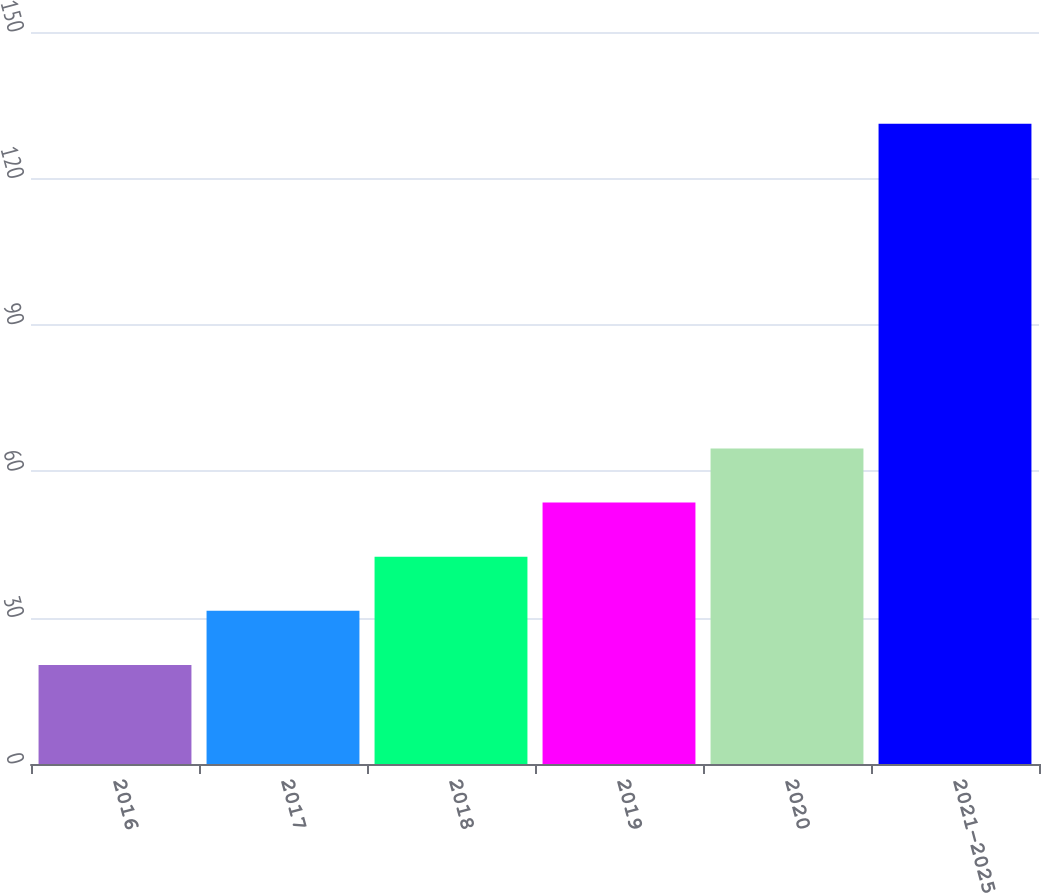<chart> <loc_0><loc_0><loc_500><loc_500><bar_chart><fcel>2016<fcel>2017<fcel>2018<fcel>2019<fcel>2020<fcel>2021-2025<nl><fcel>20.3<fcel>31.39<fcel>42.48<fcel>53.57<fcel>64.66<fcel>131.2<nl></chart> 